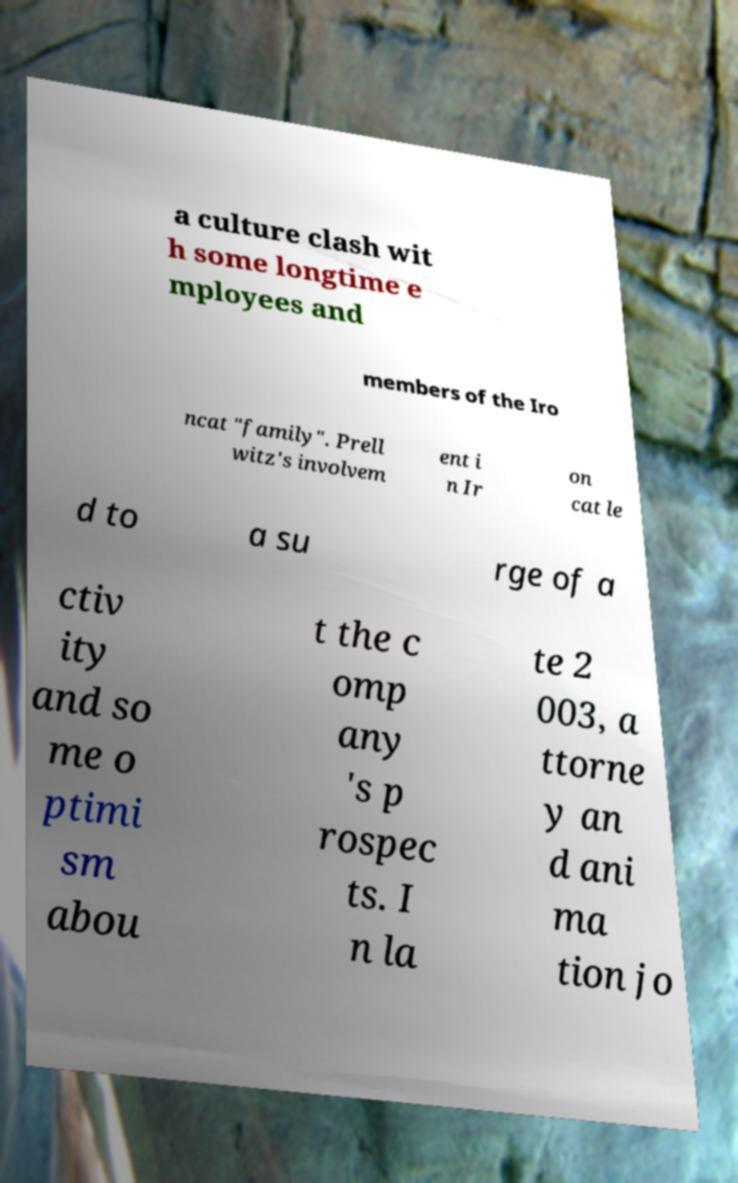There's text embedded in this image that I need extracted. Can you transcribe it verbatim? a culture clash wit h some longtime e mployees and members of the Iro ncat "family". Prell witz's involvem ent i n Ir on cat le d to a su rge of a ctiv ity and so me o ptimi sm abou t the c omp any 's p rospec ts. I n la te 2 003, a ttorne y an d ani ma tion jo 